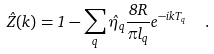Convert formula to latex. <formula><loc_0><loc_0><loc_500><loc_500>\hat { Z } ( k ) = 1 - \sum _ { q } \hat { \eta } _ { q } \frac { 8 R } { \pi l _ { q } } e ^ { - i k T _ { q } } \ \ .</formula> 